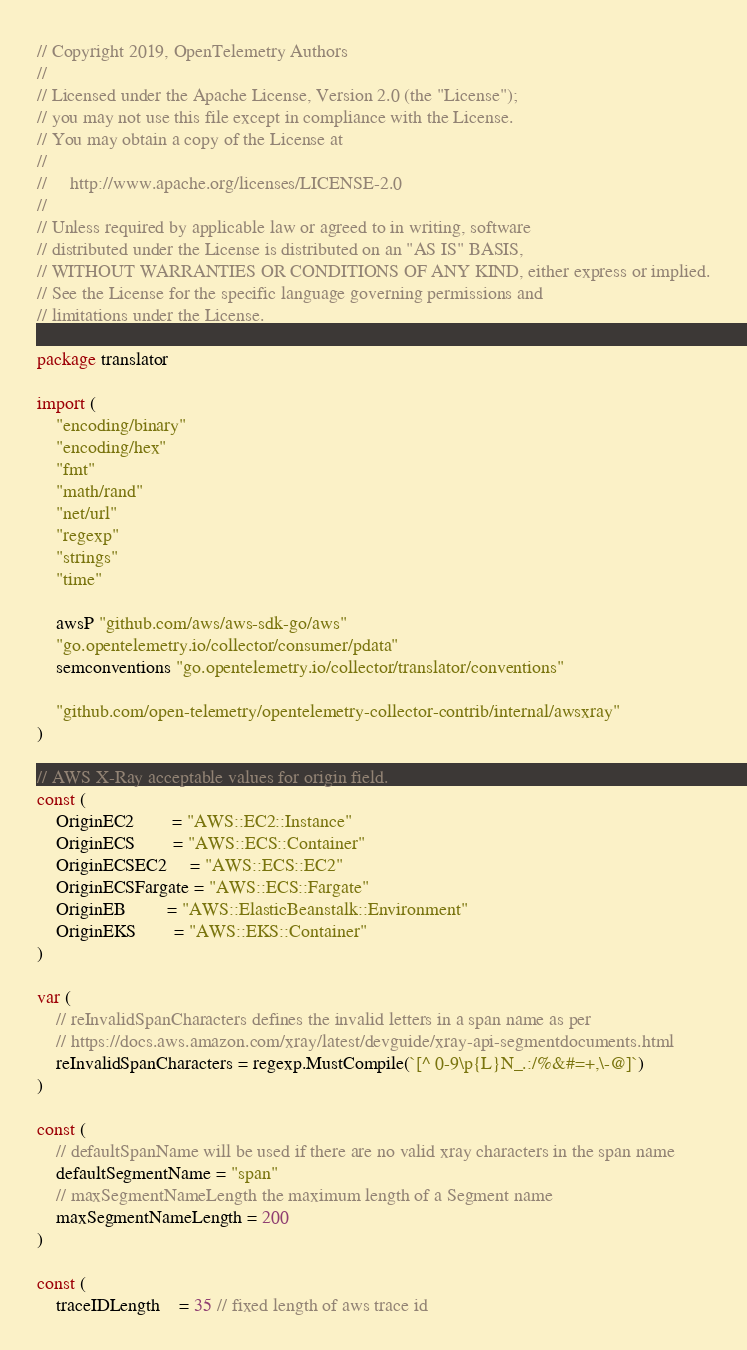Convert code to text. <code><loc_0><loc_0><loc_500><loc_500><_Go_>// Copyright 2019, OpenTelemetry Authors
//
// Licensed under the Apache License, Version 2.0 (the "License");
// you may not use this file except in compliance with the License.
// You may obtain a copy of the License at
//
//     http://www.apache.org/licenses/LICENSE-2.0
//
// Unless required by applicable law or agreed to in writing, software
// distributed under the License is distributed on an "AS IS" BASIS,
// WITHOUT WARRANTIES OR CONDITIONS OF ANY KIND, either express or implied.
// See the License for the specific language governing permissions and
// limitations under the License.

package translator

import (
	"encoding/binary"
	"encoding/hex"
	"fmt"
	"math/rand"
	"net/url"
	"regexp"
	"strings"
	"time"

	awsP "github.com/aws/aws-sdk-go/aws"
	"go.opentelemetry.io/collector/consumer/pdata"
	semconventions "go.opentelemetry.io/collector/translator/conventions"

	"github.com/open-telemetry/opentelemetry-collector-contrib/internal/awsxray"
)

// AWS X-Ray acceptable values for origin field.
const (
	OriginEC2        = "AWS::EC2::Instance"
	OriginECS        = "AWS::ECS::Container"
	OriginECSEC2     = "AWS::ECS::EC2"
	OriginECSFargate = "AWS::ECS::Fargate"
	OriginEB         = "AWS::ElasticBeanstalk::Environment"
	OriginEKS        = "AWS::EKS::Container"
)

var (
	// reInvalidSpanCharacters defines the invalid letters in a span name as per
	// https://docs.aws.amazon.com/xray/latest/devguide/xray-api-segmentdocuments.html
	reInvalidSpanCharacters = regexp.MustCompile(`[^ 0-9\p{L}N_.:/%&#=+,\-@]`)
)

const (
	// defaultSpanName will be used if there are no valid xray characters in the span name
	defaultSegmentName = "span"
	// maxSegmentNameLength the maximum length of a Segment name
	maxSegmentNameLength = 200
)

const (
	traceIDLength    = 35 // fixed length of aws trace id</code> 